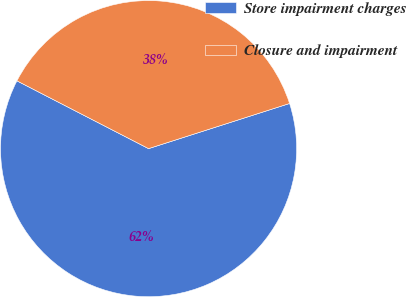<chart> <loc_0><loc_0><loc_500><loc_500><pie_chart><fcel>Store impairment charges<fcel>Closure and impairment<nl><fcel>62.5%<fcel>37.5%<nl></chart> 